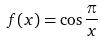<formula> <loc_0><loc_0><loc_500><loc_500>f ( x ) = \cos \frac { \pi } { x }</formula> 